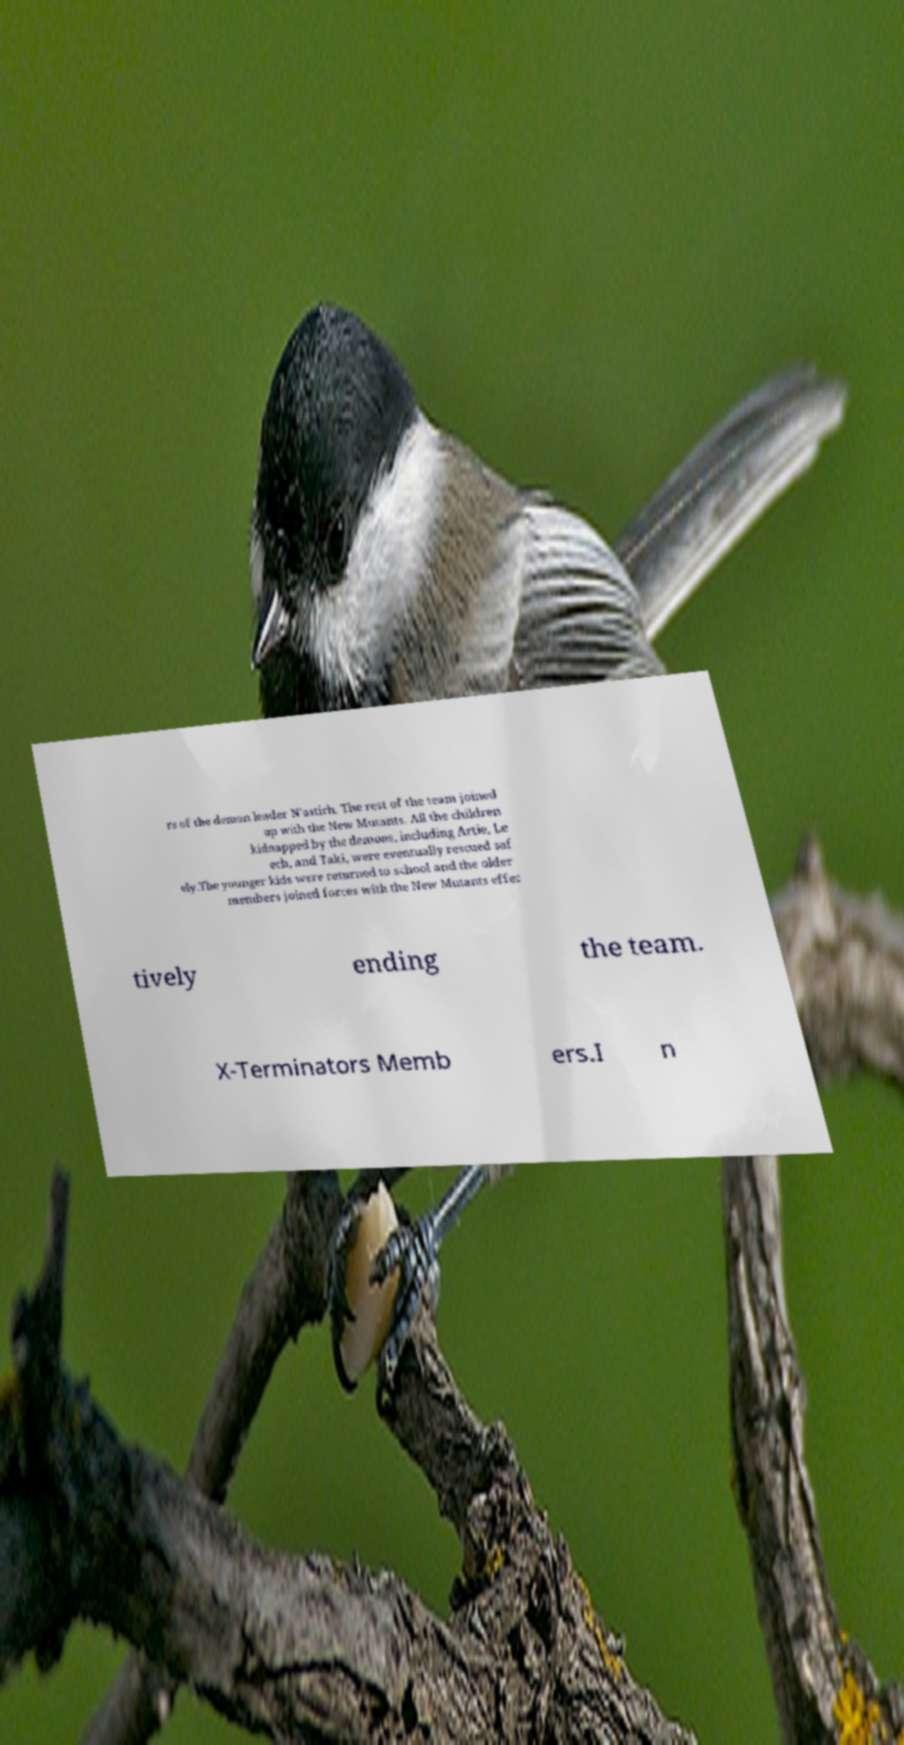Can you accurately transcribe the text from the provided image for me? rs of the demon leader N'astirh. The rest of the team joined up with the New Mutants. All the children kidnapped by the demons, including Artie, Le ech, and Taki, were eventually rescued saf ely.The younger kids were returned to school and the older members joined forces with the New Mutants effec tively ending the team. X-Terminators Memb ers.I n 